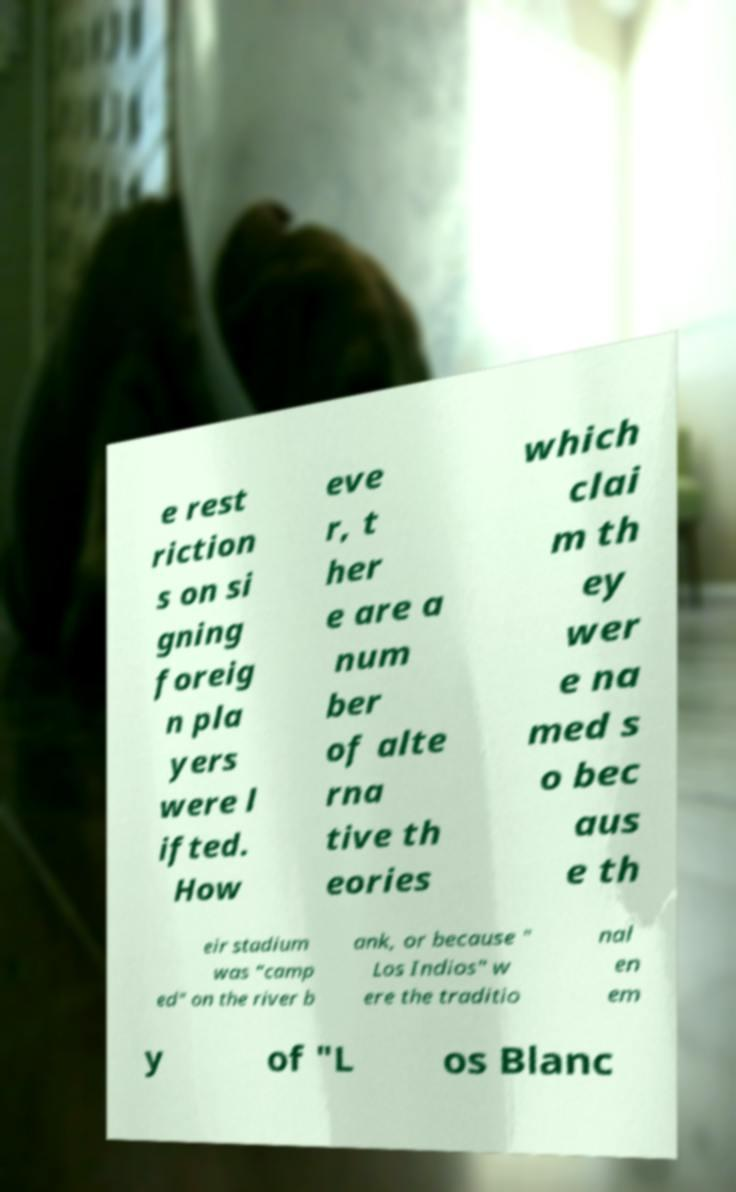Please read and relay the text visible in this image. What does it say? e rest riction s on si gning foreig n pla yers were l ifted. How eve r, t her e are a num ber of alte rna tive th eories which clai m th ey wer e na med s o bec aus e th eir stadium was "camp ed" on the river b ank, or because " Los Indios" w ere the traditio nal en em y of "L os Blanc 